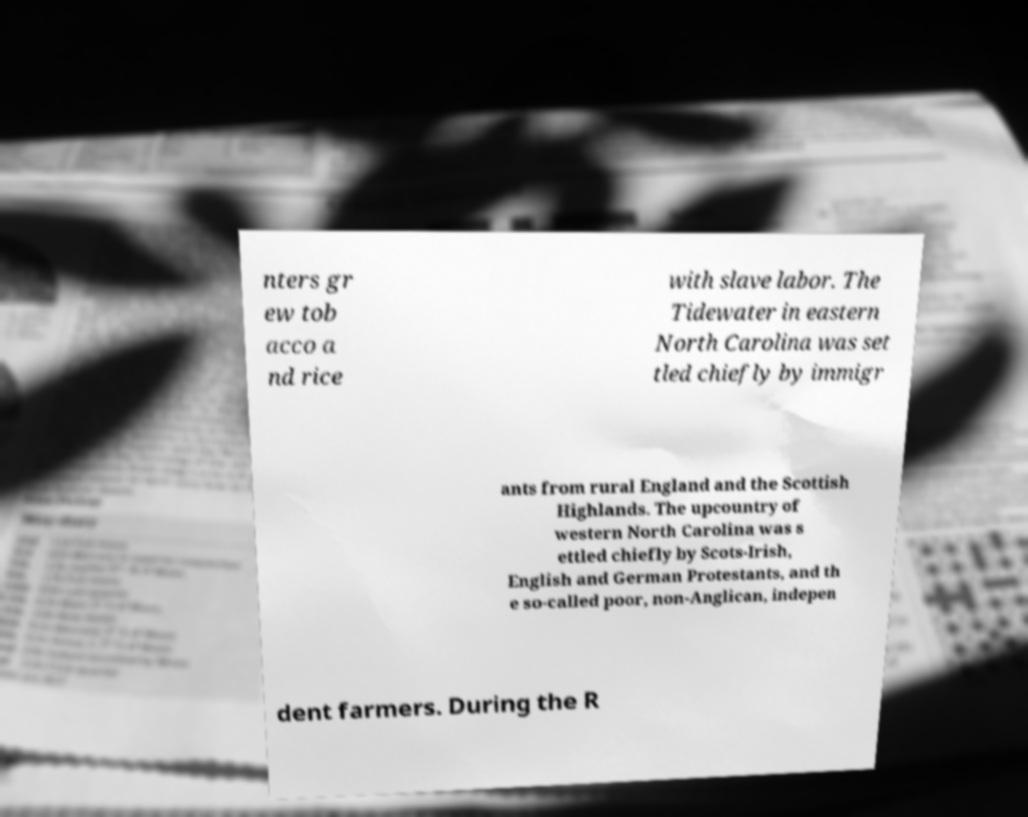For documentation purposes, I need the text within this image transcribed. Could you provide that? nters gr ew tob acco a nd rice with slave labor. The Tidewater in eastern North Carolina was set tled chiefly by immigr ants from rural England and the Scottish Highlands. The upcountry of western North Carolina was s ettled chiefly by Scots-Irish, English and German Protestants, and th e so-called poor, non-Anglican, indepen dent farmers. During the R 